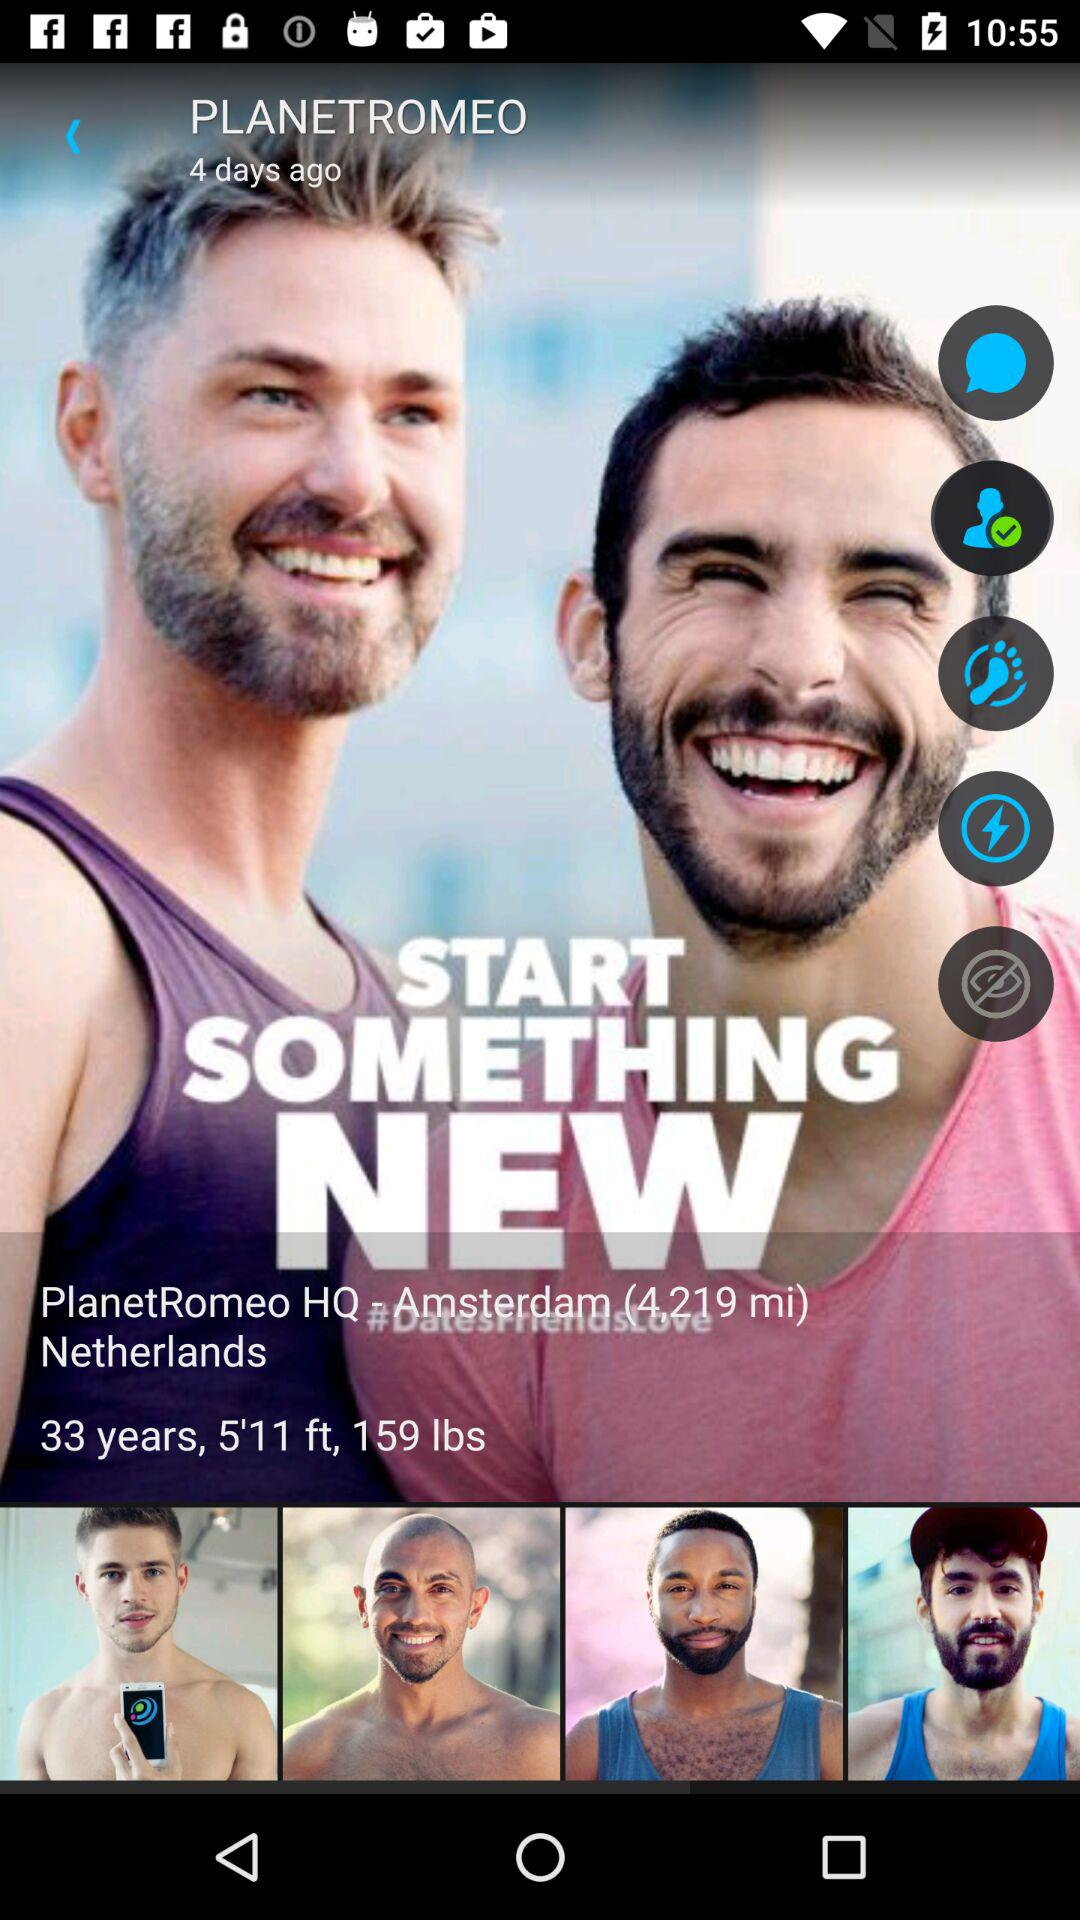How far is Amsterdam from my location? Amsterdam is 4,219 miles away from your location. 